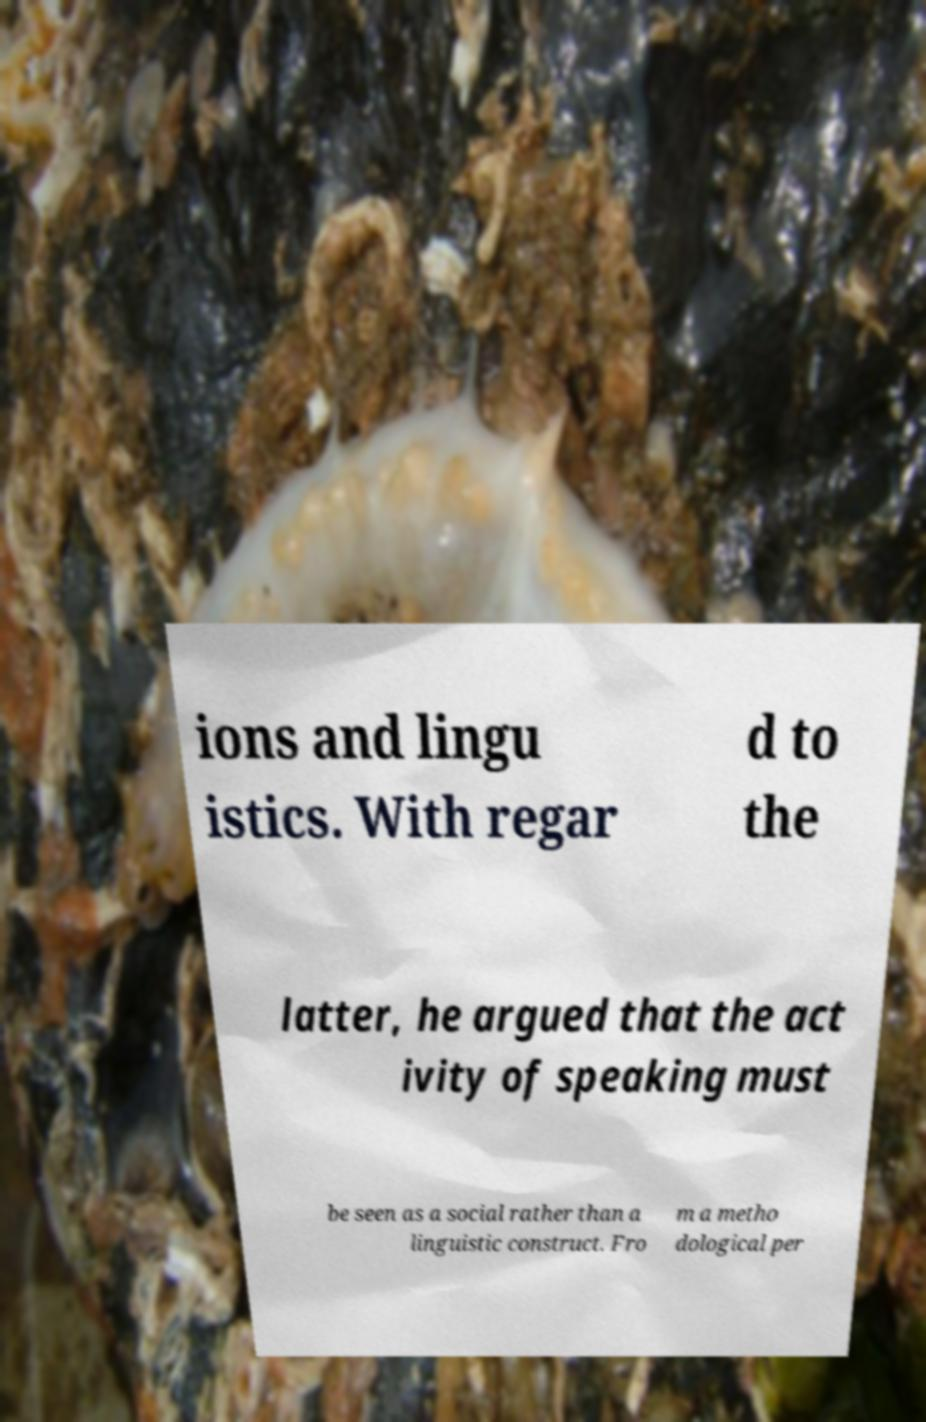Could you assist in decoding the text presented in this image and type it out clearly? ions and lingu istics. With regar d to the latter, he argued that the act ivity of speaking must be seen as a social rather than a linguistic construct. Fro m a metho dological per 